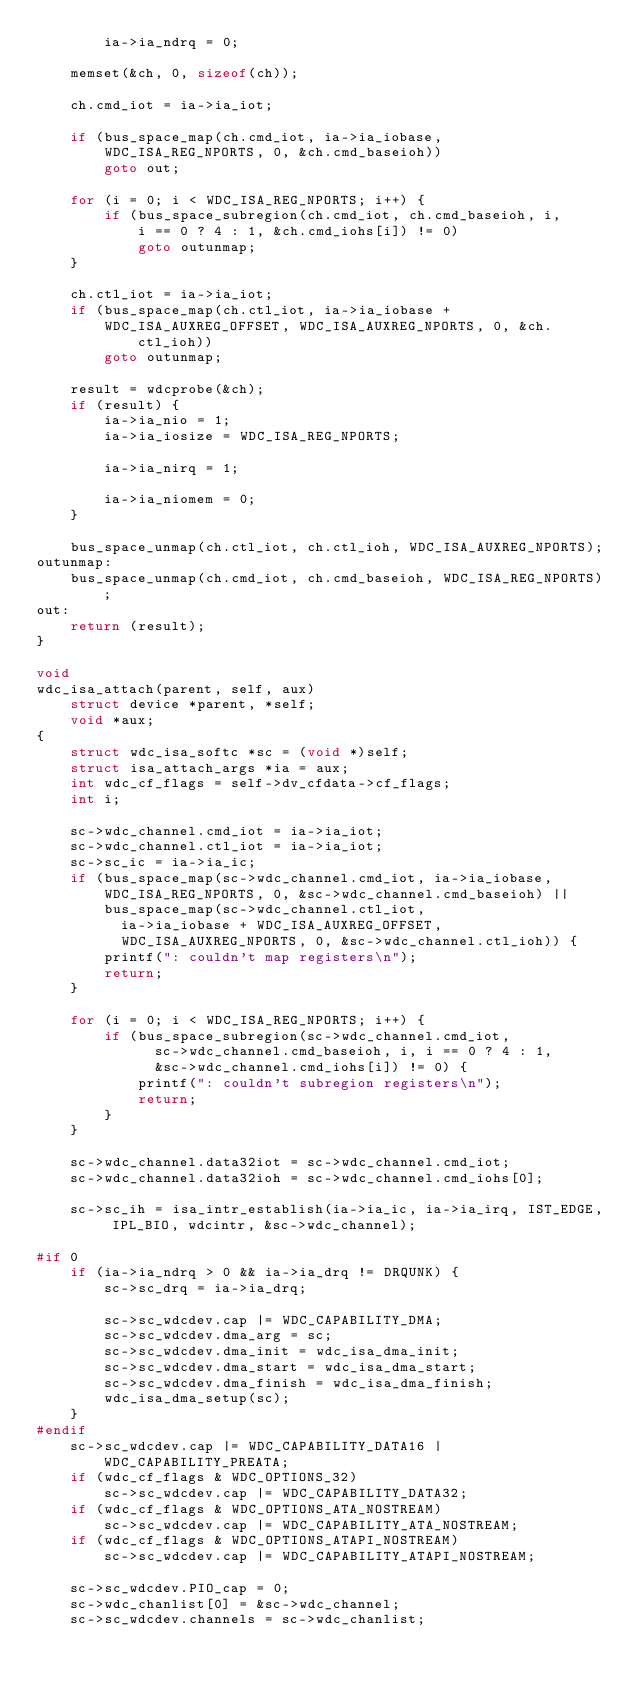Convert code to text. <code><loc_0><loc_0><loc_500><loc_500><_C_>		ia->ia_ndrq = 0;

	memset(&ch, 0, sizeof(ch));

	ch.cmd_iot = ia->ia_iot;

	if (bus_space_map(ch.cmd_iot, ia->ia_iobase,
	    WDC_ISA_REG_NPORTS, 0, &ch.cmd_baseioh))
		goto out;

	for (i = 0; i < WDC_ISA_REG_NPORTS; i++) {
		if (bus_space_subregion(ch.cmd_iot, ch.cmd_baseioh, i,
		    i == 0 ? 4 : 1, &ch.cmd_iohs[i]) != 0)
			goto outunmap;
	}

	ch.ctl_iot = ia->ia_iot;
	if (bus_space_map(ch.ctl_iot, ia->ia_iobase +
	    WDC_ISA_AUXREG_OFFSET, WDC_ISA_AUXREG_NPORTS, 0, &ch.ctl_ioh))
		goto outunmap;

	result = wdcprobe(&ch);
	if (result) {
		ia->ia_nio = 1;
		ia->ia_iosize = WDC_ISA_REG_NPORTS;

		ia->ia_nirq = 1;

		ia->ia_niomem = 0;
	}

	bus_space_unmap(ch.ctl_iot, ch.ctl_ioh, WDC_ISA_AUXREG_NPORTS);
outunmap:
	bus_space_unmap(ch.cmd_iot, ch.cmd_baseioh, WDC_ISA_REG_NPORTS);
out:
	return (result);
}

void
wdc_isa_attach(parent, self, aux)
	struct device *parent, *self;
	void *aux;
{
	struct wdc_isa_softc *sc = (void *)self;
	struct isa_attach_args *ia = aux;
	int wdc_cf_flags = self->dv_cfdata->cf_flags;
	int i;

	sc->wdc_channel.cmd_iot = ia->ia_iot;
	sc->wdc_channel.ctl_iot = ia->ia_iot;
	sc->sc_ic = ia->ia_ic;
	if (bus_space_map(sc->wdc_channel.cmd_iot, ia->ia_iobase,
	    WDC_ISA_REG_NPORTS, 0, &sc->wdc_channel.cmd_baseioh) ||
	    bus_space_map(sc->wdc_channel.ctl_iot,
	      ia->ia_iobase + WDC_ISA_AUXREG_OFFSET,
	      WDC_ISA_AUXREG_NPORTS, 0, &sc->wdc_channel.ctl_ioh)) {
		printf(": couldn't map registers\n");
		return;
	}

	for (i = 0; i < WDC_ISA_REG_NPORTS; i++) {
		if (bus_space_subregion(sc->wdc_channel.cmd_iot,
		      sc->wdc_channel.cmd_baseioh, i, i == 0 ? 4 : 1,
		      &sc->wdc_channel.cmd_iohs[i]) != 0) {
			printf(": couldn't subregion registers\n");
			return;
		}
	}

	sc->wdc_channel.data32iot = sc->wdc_channel.cmd_iot;
	sc->wdc_channel.data32ioh = sc->wdc_channel.cmd_iohs[0];

	sc->sc_ih = isa_intr_establish(ia->ia_ic, ia->ia_irq, IST_EDGE, IPL_BIO, wdcintr, &sc->wdc_channel);

#if 0
	if (ia->ia_ndrq > 0 && ia->ia_drq != DRQUNK) {
		sc->sc_drq = ia->ia_drq;

		sc->sc_wdcdev.cap |= WDC_CAPABILITY_DMA;
		sc->sc_wdcdev.dma_arg = sc;
		sc->sc_wdcdev.dma_init = wdc_isa_dma_init;
		sc->sc_wdcdev.dma_start = wdc_isa_dma_start;
		sc->sc_wdcdev.dma_finish = wdc_isa_dma_finish;
		wdc_isa_dma_setup(sc);
	}
#endif
	sc->sc_wdcdev.cap |= WDC_CAPABILITY_DATA16 | WDC_CAPABILITY_PREATA;
	if (wdc_cf_flags & WDC_OPTIONS_32)
		sc->sc_wdcdev.cap |= WDC_CAPABILITY_DATA32;
	if (wdc_cf_flags & WDC_OPTIONS_ATA_NOSTREAM)
		sc->sc_wdcdev.cap |= WDC_CAPABILITY_ATA_NOSTREAM;
	if (wdc_cf_flags & WDC_OPTIONS_ATAPI_NOSTREAM)
		sc->sc_wdcdev.cap |= WDC_CAPABILITY_ATAPI_NOSTREAM;

	sc->sc_wdcdev.PIO_cap = 0;
	sc->wdc_chanlist[0] = &sc->wdc_channel;
	sc->sc_wdcdev.channels = sc->wdc_chanlist;</code> 